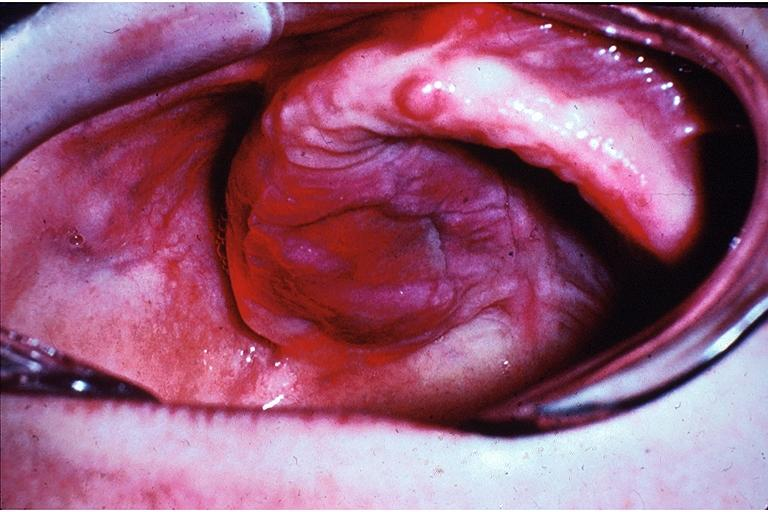does this image show lymphoproliferative disease of the palate?
Answer the question using a single word or phrase. Yes 